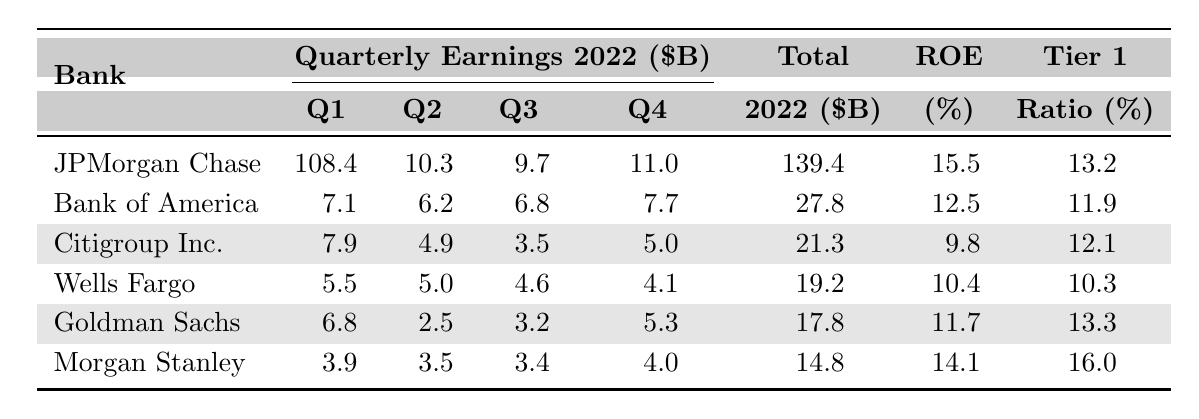What was the total earnings of JPMorgan Chase & Co. in 2022? The table shows the "Total Earnings 2022" for JPMorgan Chase & Co. as 139.4 billion dollars.
Answer: 139.4 billion dollars Which bank had the highest Return on Equity (ROE)? The "Return On Equity" column indicates JPMorgan Chase & Co. with 15.5% as the highest ROE compared to other banks.
Answer: JPMorgan Chase & Co What was the earnings of Wells Fargo & Co. in Q3 2022? The table lists the "Q3 2022 Earnings" for Wells Fargo & Co. as 4.6 billion dollars.
Answer: 4.6 billion dollars How much did Citigroup Inc. earn in total for 2022 compared to Goldman Sachs Group Inc.? The total earnings for Citigroup Inc. are 21.3 billion dollars and for Goldman Sachs Group Inc. are 17.8 billion dollars. Since 21.3 > 17.8, Citigroup Inc. earned more.
Answer: Citigroup Inc. earned more What bank had a Tier 1 Capital Ratio higher than 13%? By checking the "Tier 1" column, both JPMorgan Chase & Co. (13.2%) and Goldman Sachs Group Inc. (13.3%) have a ratio higher than 13%.
Answer: JPMorgan Chase & Co. and Goldman Sachs Group Inc What is the average total earnings of all banks listed? To find the average, sum the total earnings of all banks: (139.4 + 27.8 + 21.3 + 19.2 + 17.8 + 14.8 = 239.3) and then divide by the number of banks (6). The average is 239.3 / 6 = 39.8833.
Answer: 39.8833 billion dollars Was the total earnings of Morgan Stanley greater than 15 billion dollars? The total earnings for Morgan Stanley is 14.8 billion dollars, which is less than 15 billion dollars.
Answer: No Which bank had the lowest Q2 earnings and what amount was it? In the Q2 earnings column, Goldman Sachs Group Inc. shows the lowest earnings of 2.5 billion dollars.
Answer: Goldman Sachs Group Inc., 2.5 billion dollars What was the difference in ROE between the highest and the lowest in the table? The highest ROE is 15.5% (JPMorgan Chase & Co.) and the lowest is 9.8% (Citigroup Inc.), so the difference is 15.5 - 9.8 = 5.7%.
Answer: 5.7% How much did Bank of America earn in the 4th quarter of 2022? The table shows Bank of America's Q4 2022 earnings as 7.7 billion dollars.
Answer: 7.7 billion dollars Is it true that Citigroup Inc. had a Tier 1 Capital Ratio of 12% or lower? The Tier 1 Capital Ratio for Citigroup Inc. is 12.1%, which is greater than 12%. Therefore, the statement is false.
Answer: False 